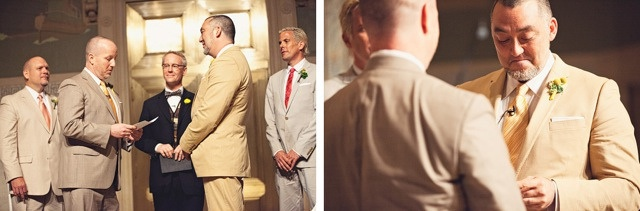Describe the objects in this image and their specific colors. I can see people in black, maroon, ivory, brown, and tan tones, people in black, beige, tan, and brown tones, people in black, tan, and gray tones, people in black and tan tones, and people in black, tan, lightgray, and darkgray tones in this image. 